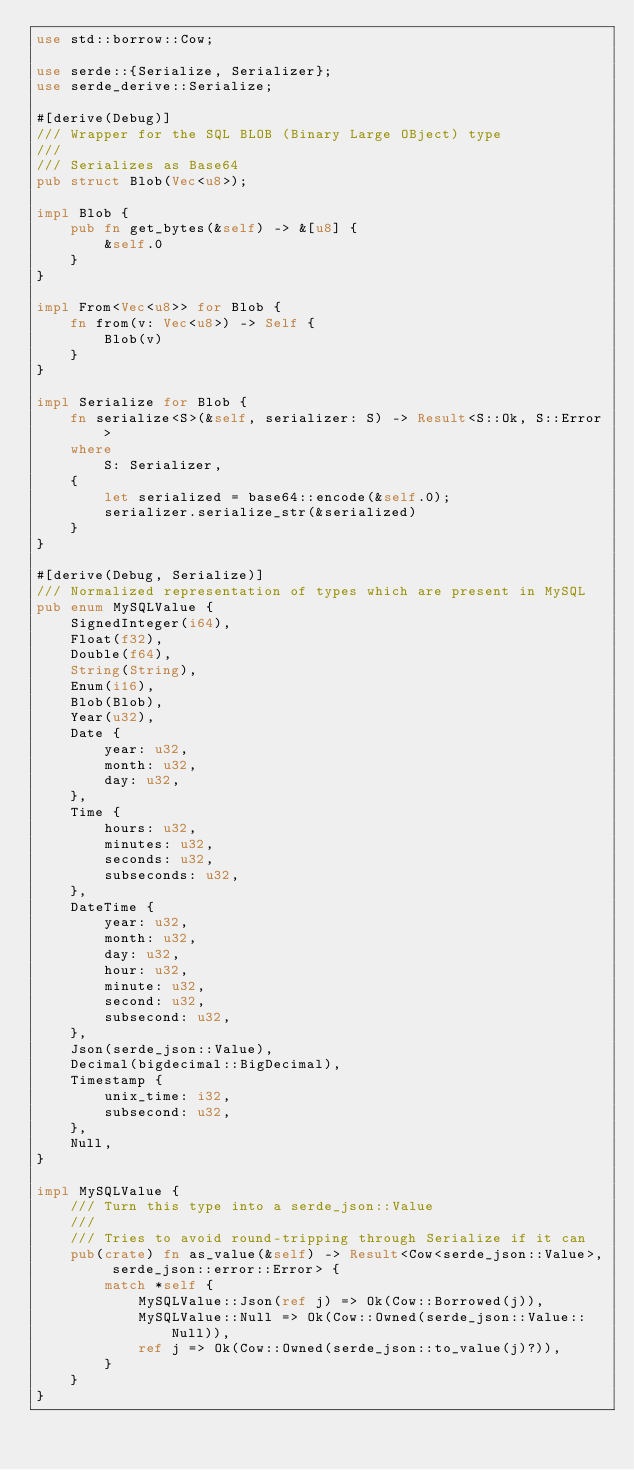Convert code to text. <code><loc_0><loc_0><loc_500><loc_500><_Rust_>use std::borrow::Cow;

use serde::{Serialize, Serializer};
use serde_derive::Serialize;

#[derive(Debug)]
/// Wrapper for the SQL BLOB (Binary Large OBject) type
///
/// Serializes as Base64
pub struct Blob(Vec<u8>);

impl Blob {
    pub fn get_bytes(&self) -> &[u8] {
        &self.0
    }
}

impl From<Vec<u8>> for Blob {
    fn from(v: Vec<u8>) -> Self {
        Blob(v)
    }
}

impl Serialize for Blob {
    fn serialize<S>(&self, serializer: S) -> Result<S::Ok, S::Error>
    where
        S: Serializer,
    {
        let serialized = base64::encode(&self.0);
        serializer.serialize_str(&serialized)
    }
}

#[derive(Debug, Serialize)]
/// Normalized representation of types which are present in MySQL
pub enum MySQLValue {
    SignedInteger(i64),
    Float(f32),
    Double(f64),
    String(String),
    Enum(i16),
    Blob(Blob),
    Year(u32),
    Date {
        year: u32,
        month: u32,
        day: u32,
    },
    Time {
        hours: u32,
        minutes: u32,
        seconds: u32,
        subseconds: u32,
    },
    DateTime {
        year: u32,
        month: u32,
        day: u32,
        hour: u32,
        minute: u32,
        second: u32,
        subsecond: u32,
    },
    Json(serde_json::Value),
    Decimal(bigdecimal::BigDecimal),
    Timestamp {
        unix_time: i32,
        subsecond: u32,
    },
    Null,
}

impl MySQLValue {
    /// Turn this type into a serde_json::Value
    ///
    /// Tries to avoid round-tripping through Serialize if it can
    pub(crate) fn as_value(&self) -> Result<Cow<serde_json::Value>, serde_json::error::Error> {
        match *self {
            MySQLValue::Json(ref j) => Ok(Cow::Borrowed(j)),
            MySQLValue::Null => Ok(Cow::Owned(serde_json::Value::Null)),
            ref j => Ok(Cow::Owned(serde_json::to_value(j)?)),
        }
    }
}
</code> 